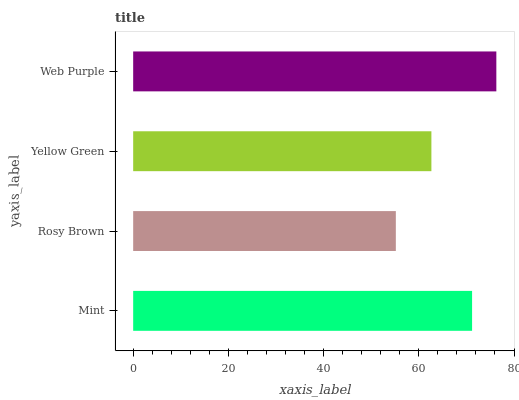Is Rosy Brown the minimum?
Answer yes or no. Yes. Is Web Purple the maximum?
Answer yes or no. Yes. Is Yellow Green the minimum?
Answer yes or no. No. Is Yellow Green the maximum?
Answer yes or no. No. Is Yellow Green greater than Rosy Brown?
Answer yes or no. Yes. Is Rosy Brown less than Yellow Green?
Answer yes or no. Yes. Is Rosy Brown greater than Yellow Green?
Answer yes or no. No. Is Yellow Green less than Rosy Brown?
Answer yes or no. No. Is Mint the high median?
Answer yes or no. Yes. Is Yellow Green the low median?
Answer yes or no. Yes. Is Rosy Brown the high median?
Answer yes or no. No. Is Mint the low median?
Answer yes or no. No. 